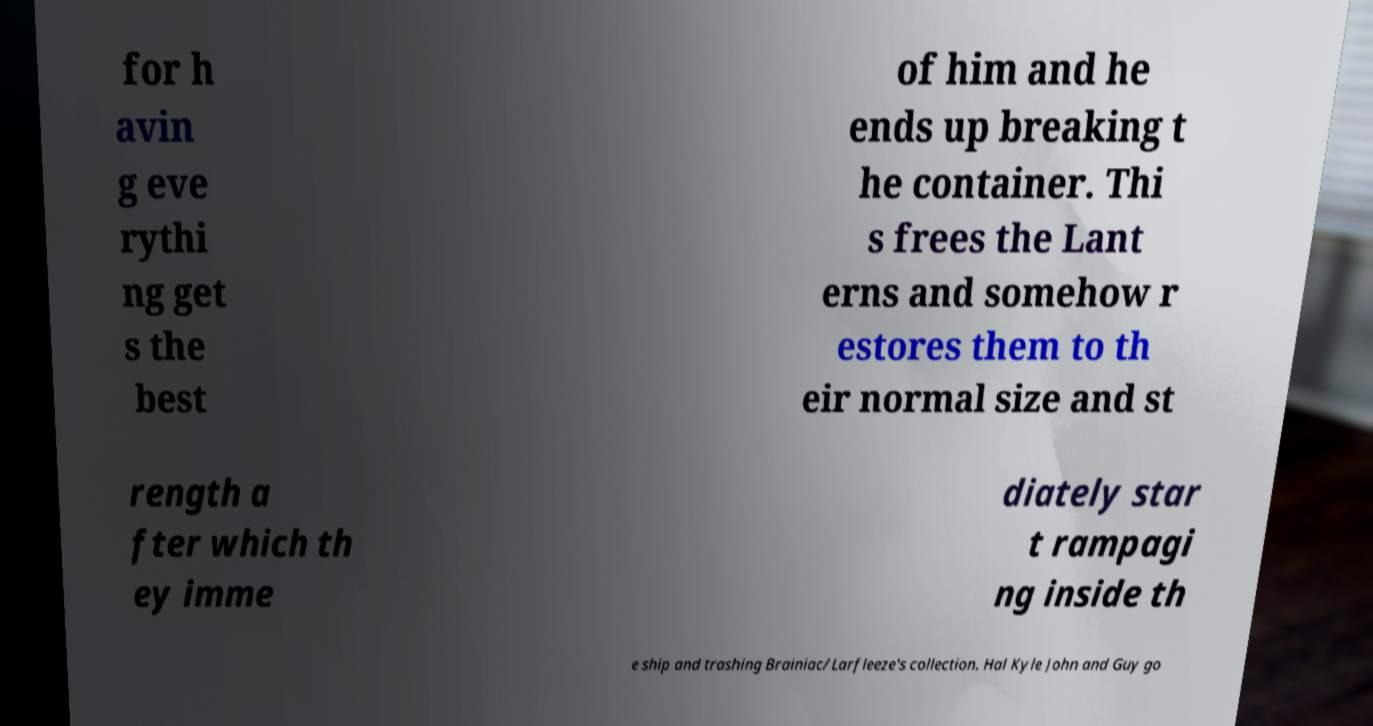Please read and relay the text visible in this image. What does it say? for h avin g eve rythi ng get s the best of him and he ends up breaking t he container. Thi s frees the Lant erns and somehow r estores them to th eir normal size and st rength a fter which th ey imme diately star t rampagi ng inside th e ship and trashing Brainiac/Larfleeze's collection. Hal Kyle John and Guy go 